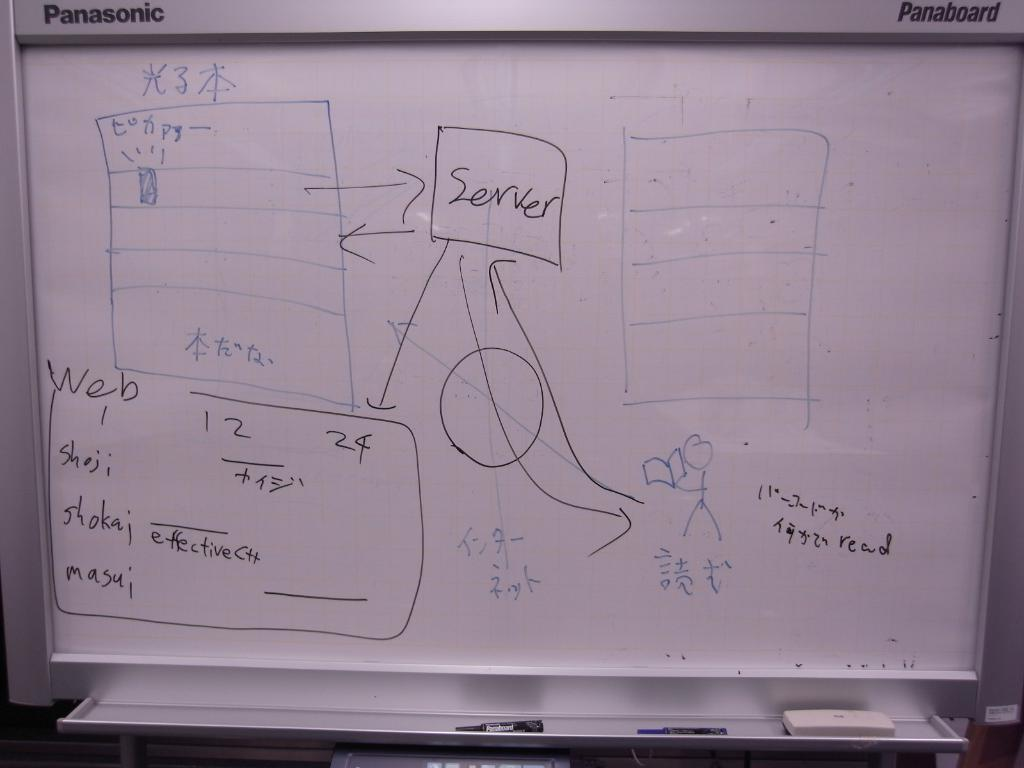<image>
Relay a brief, clear account of the picture shown. A diagram on a whiteboard with a box labeled server inside of it. 